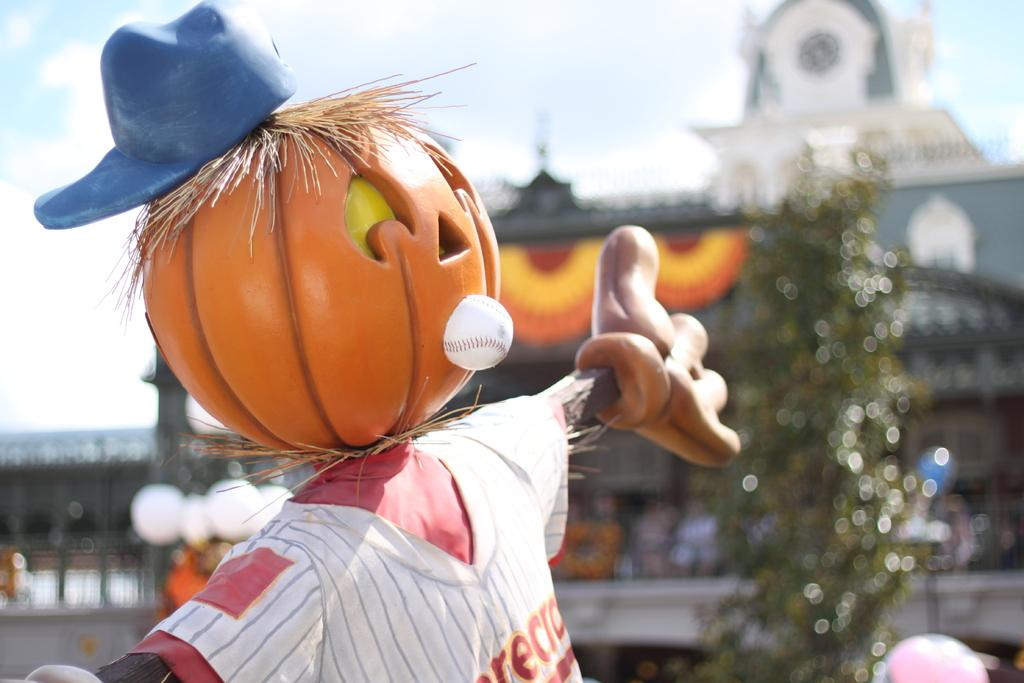What is the main subject in the image? There is a scarecrow in the image. What can be seen in the background of the image? There is a building and the sky visible in the background of the image. Can you tell me how many beggars are standing near the scarecrow in the image? There are no beggars present in the image; it only features a scarecrow. What type of knife is being used by the scarecrow in the image? There is no knife present in the image; the scarecrow is not holding or using any tool. 